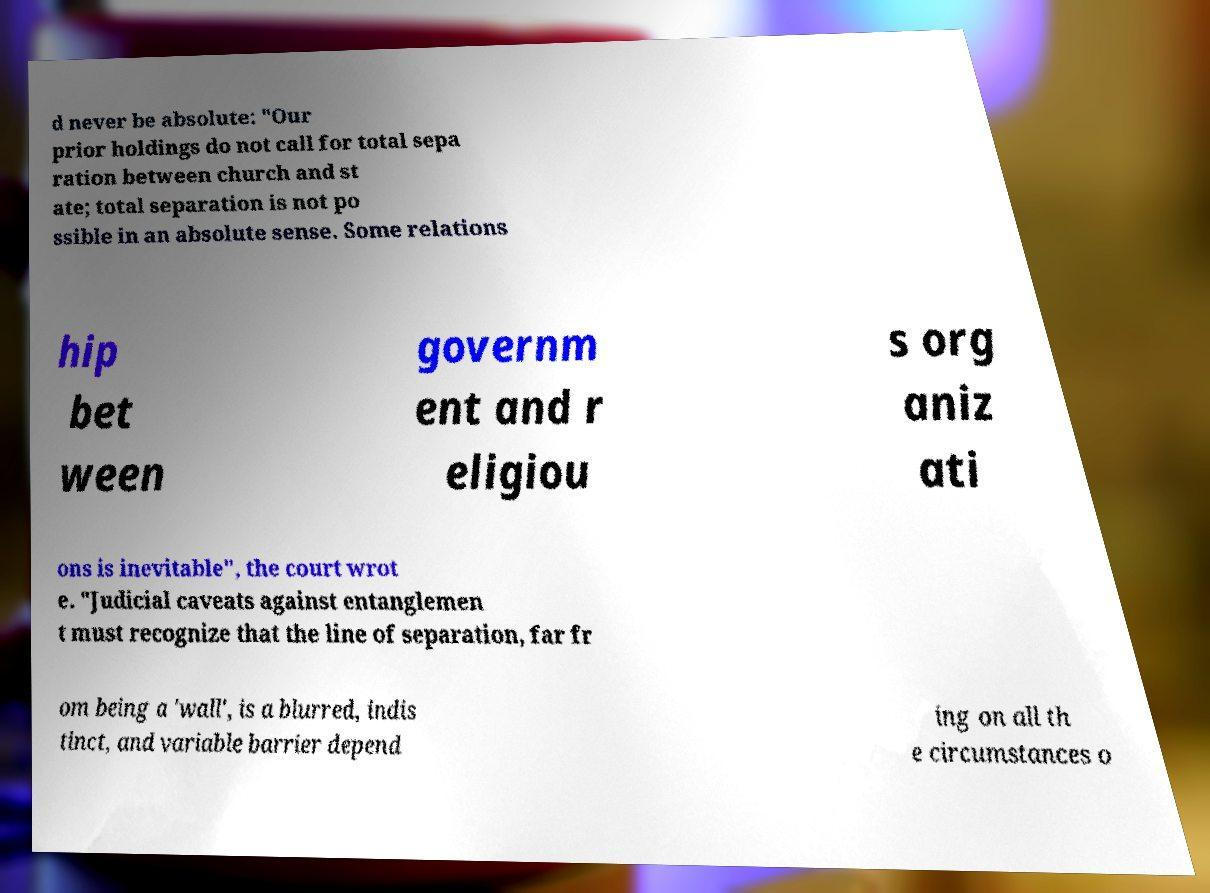I need the written content from this picture converted into text. Can you do that? d never be absolute: "Our prior holdings do not call for total sepa ration between church and st ate; total separation is not po ssible in an absolute sense. Some relations hip bet ween governm ent and r eligiou s org aniz ati ons is inevitable", the court wrot e. "Judicial caveats against entanglemen t must recognize that the line of separation, far fr om being a 'wall', is a blurred, indis tinct, and variable barrier depend ing on all th e circumstances o 